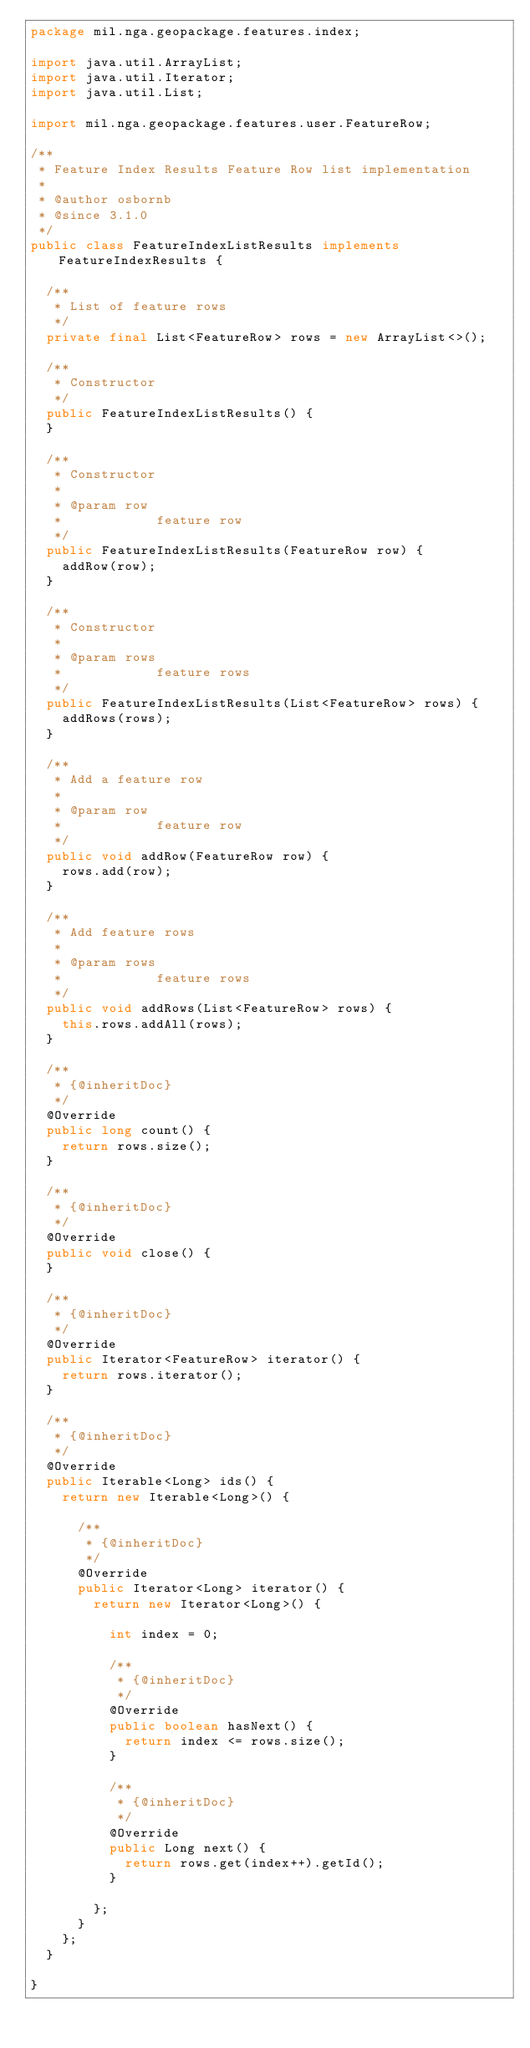Convert code to text. <code><loc_0><loc_0><loc_500><loc_500><_Java_>package mil.nga.geopackage.features.index;

import java.util.ArrayList;
import java.util.Iterator;
import java.util.List;

import mil.nga.geopackage.features.user.FeatureRow;

/**
 * Feature Index Results Feature Row list implementation
 *
 * @author osbornb
 * @since 3.1.0
 */
public class FeatureIndexListResults implements FeatureIndexResults {

	/**
	 * List of feature rows
	 */
	private final List<FeatureRow> rows = new ArrayList<>();

	/**
	 * Constructor
	 */
	public FeatureIndexListResults() {
	}

	/**
	 * Constructor
	 *
	 * @param row
	 *            feature row
	 */
	public FeatureIndexListResults(FeatureRow row) {
		addRow(row);
	}

	/**
	 * Constructor
	 *
	 * @param rows
	 *            feature rows
	 */
	public FeatureIndexListResults(List<FeatureRow> rows) {
		addRows(rows);
	}

	/**
	 * Add a feature row
	 *
	 * @param row
	 *            feature row
	 */
	public void addRow(FeatureRow row) {
		rows.add(row);
	}

	/**
	 * Add feature rows
	 *
	 * @param rows
	 *            feature rows
	 */
	public void addRows(List<FeatureRow> rows) {
		this.rows.addAll(rows);
	}

	/**
	 * {@inheritDoc}
	 */
	@Override
	public long count() {
		return rows.size();
	}

	/**
	 * {@inheritDoc}
	 */
	@Override
	public void close() {
	}

	/**
	 * {@inheritDoc}
	 */
	@Override
	public Iterator<FeatureRow> iterator() {
		return rows.iterator();
	}

	/**
	 * {@inheritDoc}
	 */
	@Override
	public Iterable<Long> ids() {
		return new Iterable<Long>() {

			/**
			 * {@inheritDoc}
			 */
			@Override
			public Iterator<Long> iterator() {
				return new Iterator<Long>() {

					int index = 0;

					/**
					 * {@inheritDoc}
					 */
					@Override
					public boolean hasNext() {
						return index <= rows.size();
					}

					/**
					 * {@inheritDoc}
					 */
					@Override
					public Long next() {
						return rows.get(index++).getId();
					}

				};
			}
		};
	}

}
</code> 